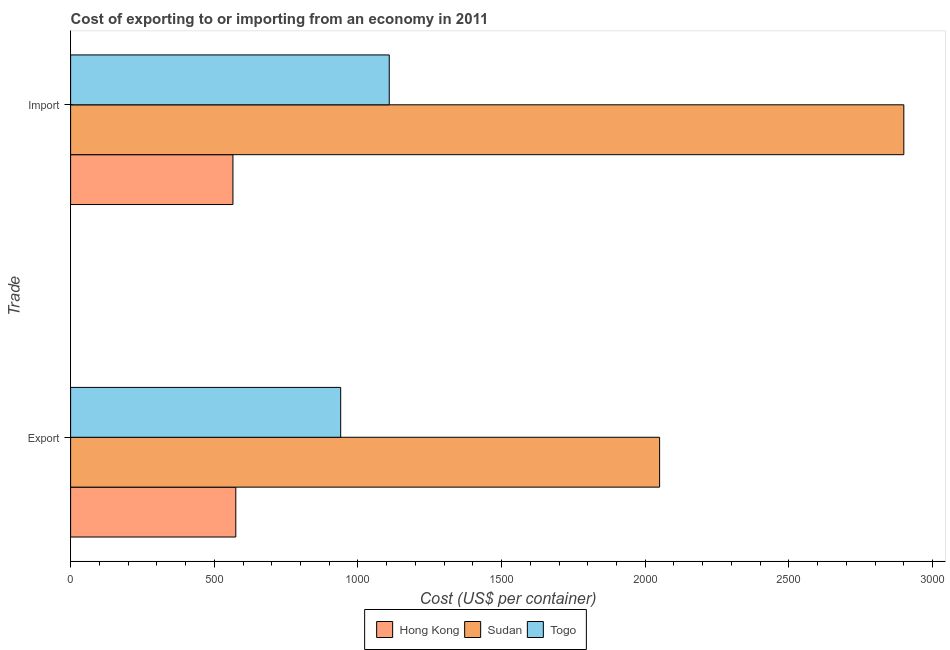How many different coloured bars are there?
Your answer should be compact. 3. Are the number of bars on each tick of the Y-axis equal?
Make the answer very short. Yes. How many bars are there on the 2nd tick from the top?
Provide a short and direct response. 3. What is the label of the 2nd group of bars from the top?
Your response must be concise. Export. What is the import cost in Sudan?
Provide a succinct answer. 2900. Across all countries, what is the maximum import cost?
Make the answer very short. 2900. Across all countries, what is the minimum import cost?
Provide a succinct answer. 565. In which country was the export cost maximum?
Offer a terse response. Sudan. In which country was the import cost minimum?
Offer a very short reply. Hong Kong. What is the total import cost in the graph?
Provide a succinct answer. 4574. What is the difference between the import cost in Hong Kong and that in Sudan?
Ensure brevity in your answer.  -2335. What is the difference between the export cost in Hong Kong and the import cost in Togo?
Provide a succinct answer. -534. What is the average import cost per country?
Give a very brief answer. 1524.67. What is the difference between the export cost and import cost in Sudan?
Ensure brevity in your answer.  -850. What is the ratio of the export cost in Sudan to that in Hong Kong?
Give a very brief answer. 3.57. What does the 3rd bar from the top in Import represents?
Provide a short and direct response. Hong Kong. What does the 1st bar from the bottom in Export represents?
Your answer should be very brief. Hong Kong. Are all the bars in the graph horizontal?
Your response must be concise. Yes. How many countries are there in the graph?
Provide a short and direct response. 3. Are the values on the major ticks of X-axis written in scientific E-notation?
Ensure brevity in your answer.  No. Does the graph contain any zero values?
Your response must be concise. No. How are the legend labels stacked?
Keep it short and to the point. Horizontal. What is the title of the graph?
Your answer should be very brief. Cost of exporting to or importing from an economy in 2011. What is the label or title of the X-axis?
Your answer should be compact. Cost (US$ per container). What is the label or title of the Y-axis?
Your answer should be very brief. Trade. What is the Cost (US$ per container) in Hong Kong in Export?
Provide a succinct answer. 575. What is the Cost (US$ per container) in Sudan in Export?
Offer a very short reply. 2050. What is the Cost (US$ per container) in Togo in Export?
Provide a succinct answer. 940. What is the Cost (US$ per container) in Hong Kong in Import?
Provide a succinct answer. 565. What is the Cost (US$ per container) in Sudan in Import?
Your response must be concise. 2900. What is the Cost (US$ per container) of Togo in Import?
Your answer should be compact. 1109. Across all Trade, what is the maximum Cost (US$ per container) of Hong Kong?
Your answer should be very brief. 575. Across all Trade, what is the maximum Cost (US$ per container) of Sudan?
Give a very brief answer. 2900. Across all Trade, what is the maximum Cost (US$ per container) in Togo?
Ensure brevity in your answer.  1109. Across all Trade, what is the minimum Cost (US$ per container) in Hong Kong?
Your answer should be very brief. 565. Across all Trade, what is the minimum Cost (US$ per container) in Sudan?
Provide a short and direct response. 2050. Across all Trade, what is the minimum Cost (US$ per container) in Togo?
Offer a terse response. 940. What is the total Cost (US$ per container) of Hong Kong in the graph?
Keep it short and to the point. 1140. What is the total Cost (US$ per container) of Sudan in the graph?
Make the answer very short. 4950. What is the total Cost (US$ per container) in Togo in the graph?
Keep it short and to the point. 2049. What is the difference between the Cost (US$ per container) of Sudan in Export and that in Import?
Your answer should be compact. -850. What is the difference between the Cost (US$ per container) in Togo in Export and that in Import?
Your answer should be very brief. -169. What is the difference between the Cost (US$ per container) of Hong Kong in Export and the Cost (US$ per container) of Sudan in Import?
Provide a short and direct response. -2325. What is the difference between the Cost (US$ per container) in Hong Kong in Export and the Cost (US$ per container) in Togo in Import?
Offer a very short reply. -534. What is the difference between the Cost (US$ per container) in Sudan in Export and the Cost (US$ per container) in Togo in Import?
Ensure brevity in your answer.  941. What is the average Cost (US$ per container) of Hong Kong per Trade?
Offer a terse response. 570. What is the average Cost (US$ per container) in Sudan per Trade?
Your answer should be very brief. 2475. What is the average Cost (US$ per container) in Togo per Trade?
Provide a short and direct response. 1024.5. What is the difference between the Cost (US$ per container) in Hong Kong and Cost (US$ per container) in Sudan in Export?
Give a very brief answer. -1475. What is the difference between the Cost (US$ per container) in Hong Kong and Cost (US$ per container) in Togo in Export?
Offer a very short reply. -365. What is the difference between the Cost (US$ per container) of Sudan and Cost (US$ per container) of Togo in Export?
Your answer should be very brief. 1110. What is the difference between the Cost (US$ per container) in Hong Kong and Cost (US$ per container) in Sudan in Import?
Make the answer very short. -2335. What is the difference between the Cost (US$ per container) of Hong Kong and Cost (US$ per container) of Togo in Import?
Make the answer very short. -544. What is the difference between the Cost (US$ per container) in Sudan and Cost (US$ per container) in Togo in Import?
Your response must be concise. 1791. What is the ratio of the Cost (US$ per container) in Hong Kong in Export to that in Import?
Your response must be concise. 1.02. What is the ratio of the Cost (US$ per container) of Sudan in Export to that in Import?
Keep it short and to the point. 0.71. What is the ratio of the Cost (US$ per container) in Togo in Export to that in Import?
Offer a terse response. 0.85. What is the difference between the highest and the second highest Cost (US$ per container) of Sudan?
Provide a short and direct response. 850. What is the difference between the highest and the second highest Cost (US$ per container) in Togo?
Your answer should be compact. 169. What is the difference between the highest and the lowest Cost (US$ per container) in Hong Kong?
Provide a succinct answer. 10. What is the difference between the highest and the lowest Cost (US$ per container) of Sudan?
Your answer should be very brief. 850. What is the difference between the highest and the lowest Cost (US$ per container) in Togo?
Offer a terse response. 169. 